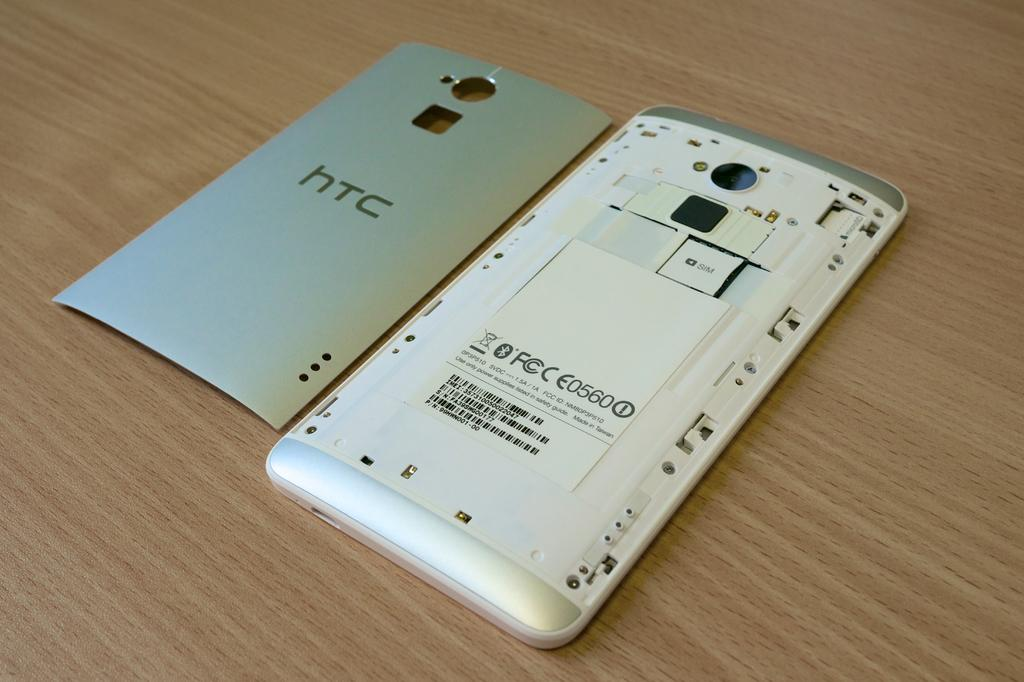<image>
Create a compact narrative representing the image presented. A HTC phone has the back cover taken off of it. 